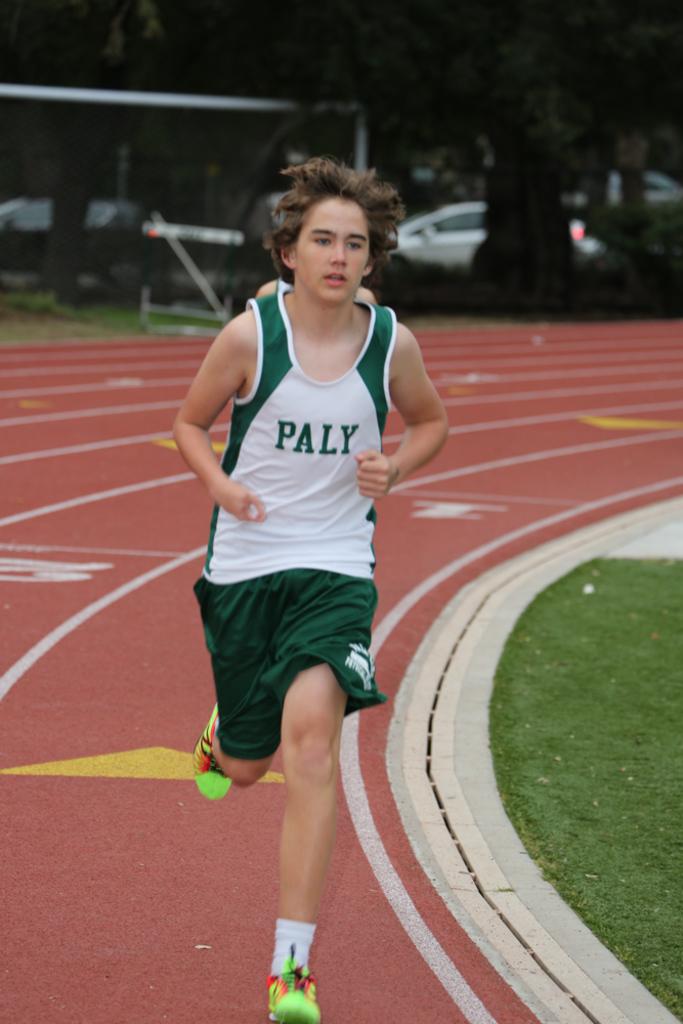Is he from paly?
Your answer should be very brief. Yes. What does the runner's jersey read?
Keep it short and to the point. Paly. 